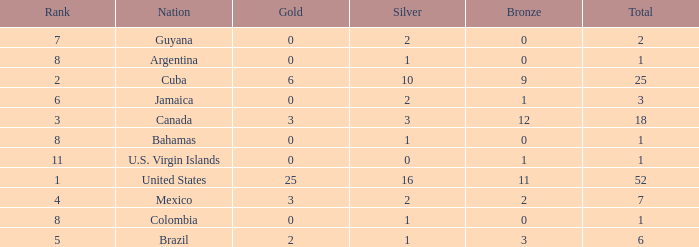What is the fewest number of silver medals a nation who ranked below 8 received? 0.0. 